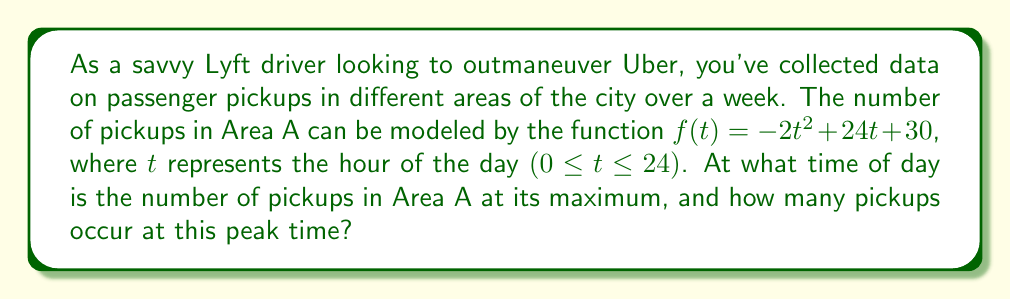Can you solve this math problem? To solve this problem, we need to find the maximum value of the quadratic function $f(t) = -2t^2 + 24t + 30$.

1) The graph of this quadratic function is a parabola that opens downward (because the coefficient of $t^2$ is negative). The maximum point occurs at the vertex of this parabola.

2) For a quadratic function in the form $f(t) = at^2 + bt + c$, the t-coordinate of the vertex is given by $t = -\frac{b}{2a}$.

3) In our function, $a = -2$ and $b = 24$. So:

   $t = -\frac{24}{2(-2)} = -\frac{24}{-4} = 6$

4) This means the maximum number of pickups occurs at $t = 6$, or 6:00 AM.

5) To find the number of pickups at this peak time, we substitute $t = 6$ into our original function:

   $f(6) = -2(6)^2 + 24(6) + 30$
         $= -2(36) + 144 + 30$
         $= -72 + 144 + 30$
         $= 102$

Therefore, the maximum number of pickups is 102, occurring at 6:00 AM.
Answer: The number of pickups in Area A is at its maximum at 6:00 AM, with 102 pickups occurring at this peak time. 